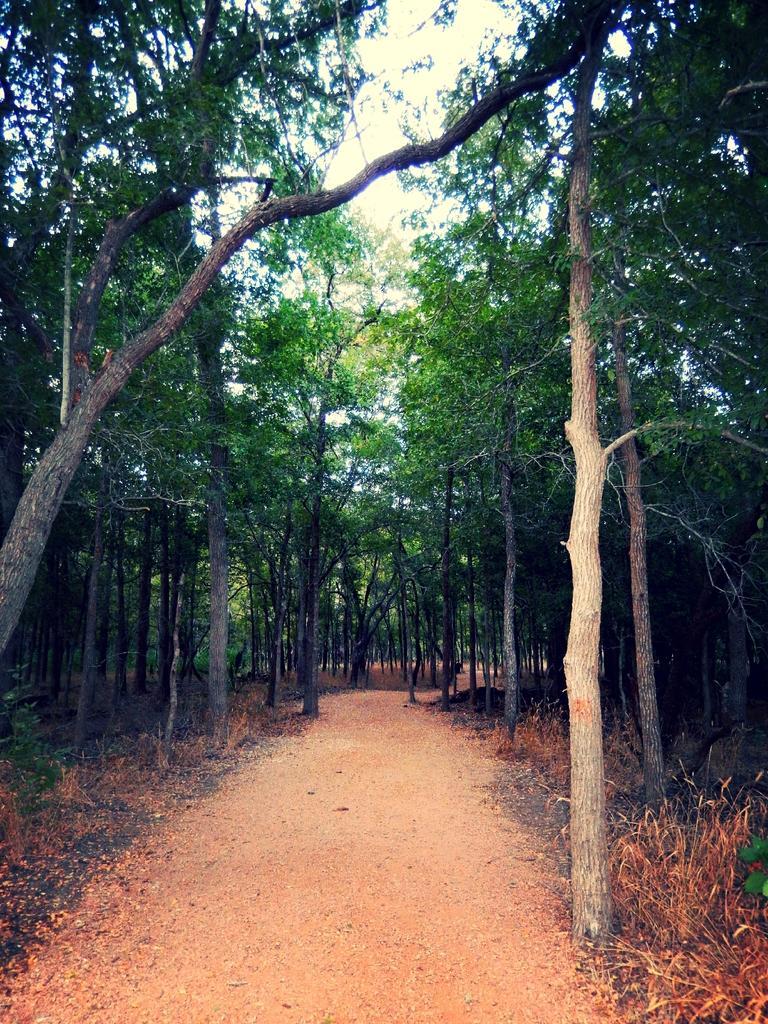How would you summarize this image in a sentence or two? This image is taken in outdoors. At the bottom of the image there is a ground with grass on it. In the background there are many trees. 